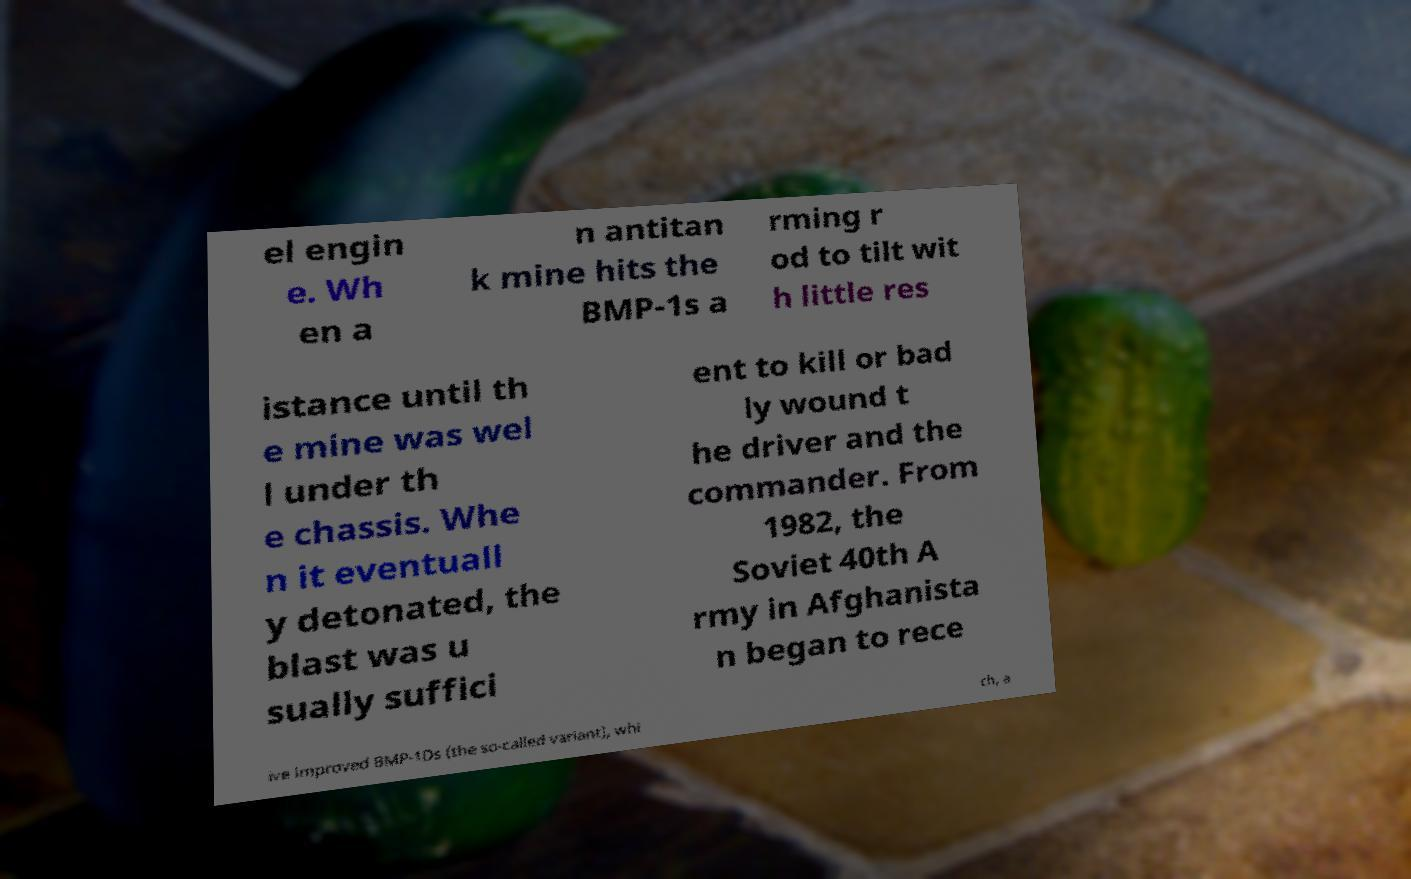There's text embedded in this image that I need extracted. Can you transcribe it verbatim? el engin e. Wh en a n antitan k mine hits the BMP-1s a rming r od to tilt wit h little res istance until th e mine was wel l under th e chassis. Whe n it eventuall y detonated, the blast was u sually suffici ent to kill or bad ly wound t he driver and the commander. From 1982, the Soviet 40th A rmy in Afghanista n began to rece ive improved BMP-1Ds (the so-called variant), whi ch, a 